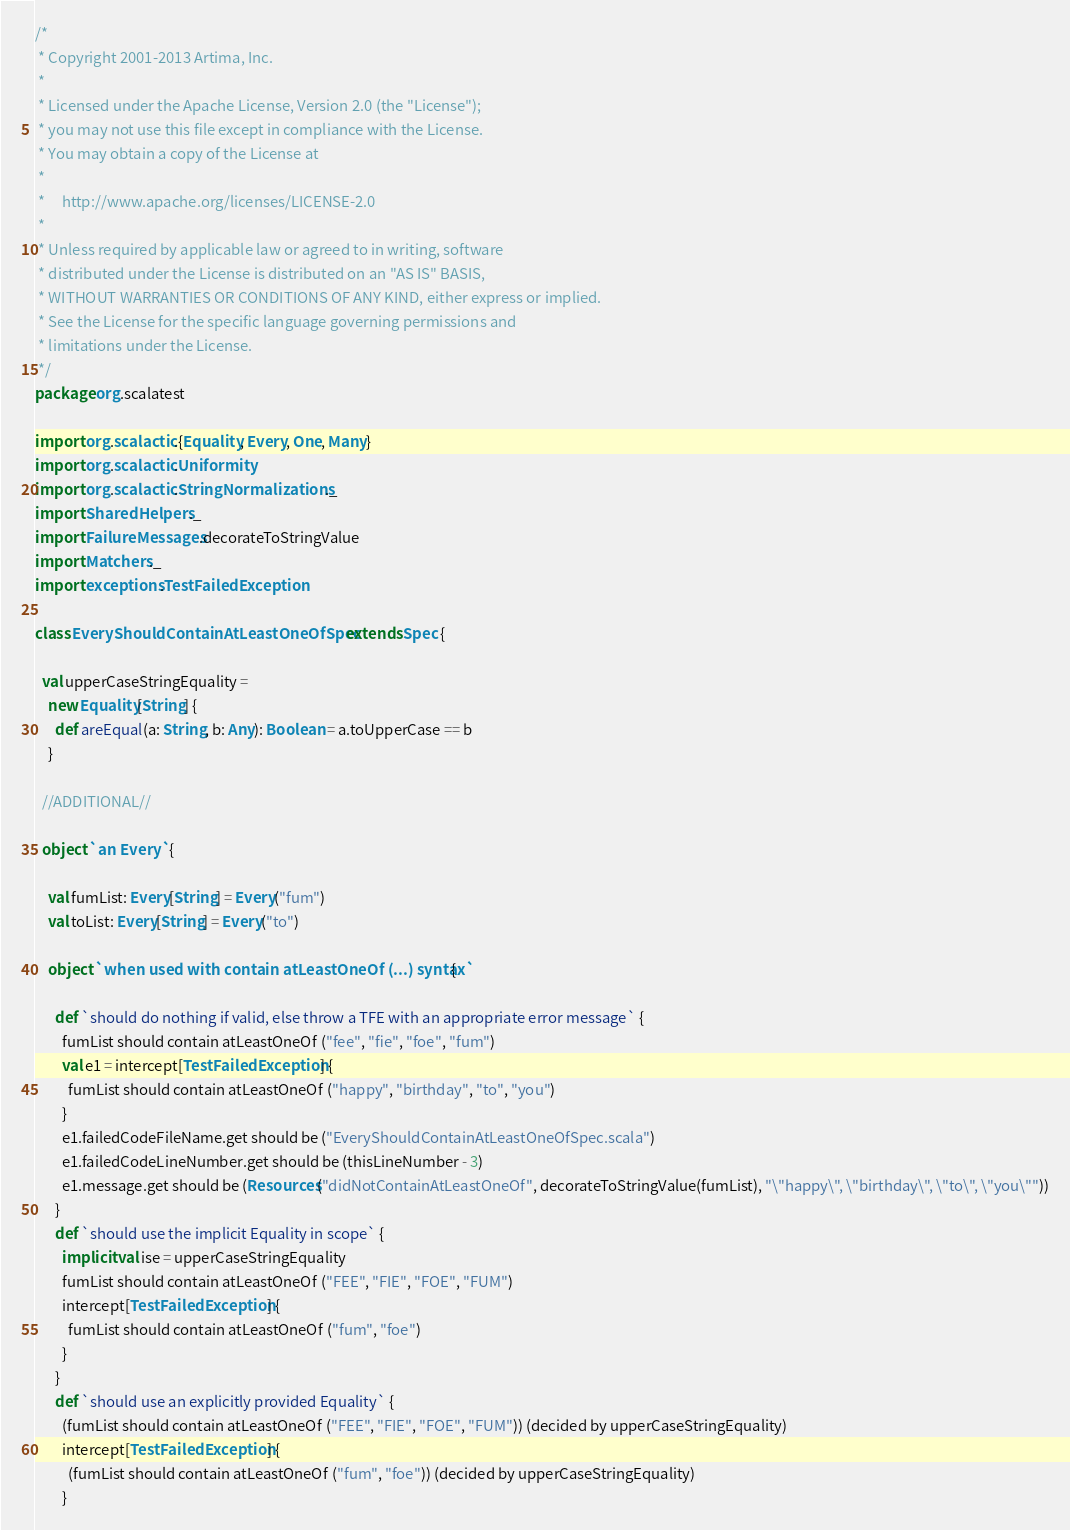<code> <loc_0><loc_0><loc_500><loc_500><_Scala_>/*
 * Copyright 2001-2013 Artima, Inc.
 *
 * Licensed under the Apache License, Version 2.0 (the "License");
 * you may not use this file except in compliance with the License.
 * You may obtain a copy of the License at
 *
 *     http://www.apache.org/licenses/LICENSE-2.0
 *
 * Unless required by applicable law or agreed to in writing, software
 * distributed under the License is distributed on an "AS IS" BASIS,
 * WITHOUT WARRANTIES OR CONDITIONS OF ANY KIND, either express or implied.
 * See the License for the specific language governing permissions and
 * limitations under the License.
 */
package org.scalatest

import org.scalactic.{Equality, Every, One, Many}
import org.scalactic.Uniformity
import org.scalactic.StringNormalizations._
import SharedHelpers._
import FailureMessages.decorateToStringValue
import Matchers._
import exceptions.TestFailedException

class EveryShouldContainAtLeastOneOfSpec extends Spec {

  val upperCaseStringEquality =
    new Equality[String] {
      def areEqual(a: String, b: Any): Boolean = a.toUpperCase == b
    }

  //ADDITIONAL//

  object `an Every` {

    val fumList: Every[String] = Every("fum")
    val toList: Every[String] = Every("to")

    object `when used with contain atLeastOneOf (...) syntax` {

      def `should do nothing if valid, else throw a TFE with an appropriate error message` {
        fumList should contain atLeastOneOf ("fee", "fie", "foe", "fum")
        val e1 = intercept[TestFailedException] {
          fumList should contain atLeastOneOf ("happy", "birthday", "to", "you")
        }
        e1.failedCodeFileName.get should be ("EveryShouldContainAtLeastOneOfSpec.scala")
        e1.failedCodeLineNumber.get should be (thisLineNumber - 3)
        e1.message.get should be (Resources("didNotContainAtLeastOneOf", decorateToStringValue(fumList), "\"happy\", \"birthday\", \"to\", \"you\""))
      }
      def `should use the implicit Equality in scope` {
        implicit val ise = upperCaseStringEquality
        fumList should contain atLeastOneOf ("FEE", "FIE", "FOE", "FUM")
        intercept[TestFailedException] {
          fumList should contain atLeastOneOf ("fum", "foe")
        }
      }
      def `should use an explicitly provided Equality` {
        (fumList should contain atLeastOneOf ("FEE", "FIE", "FOE", "FUM")) (decided by upperCaseStringEquality)
        intercept[TestFailedException] {
          (fumList should contain atLeastOneOf ("fum", "foe")) (decided by upperCaseStringEquality)
        }</code> 